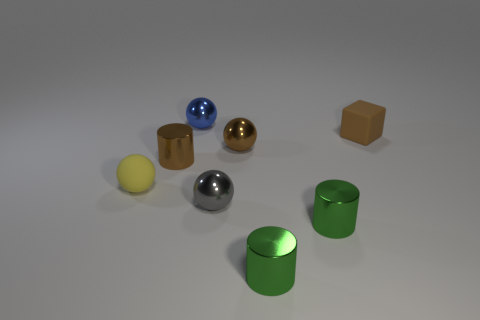Subtract all brown cylinders. Subtract all blue blocks. How many cylinders are left? 2 Add 1 big blue metal things. How many objects exist? 9 Subtract all cubes. How many objects are left? 7 Add 7 tiny gray spheres. How many tiny gray spheres are left? 8 Add 7 gray metallic cylinders. How many gray metallic cylinders exist? 7 Subtract 1 yellow spheres. How many objects are left? 7 Subtract all blue metal objects. Subtract all tiny brown shiny cylinders. How many objects are left? 6 